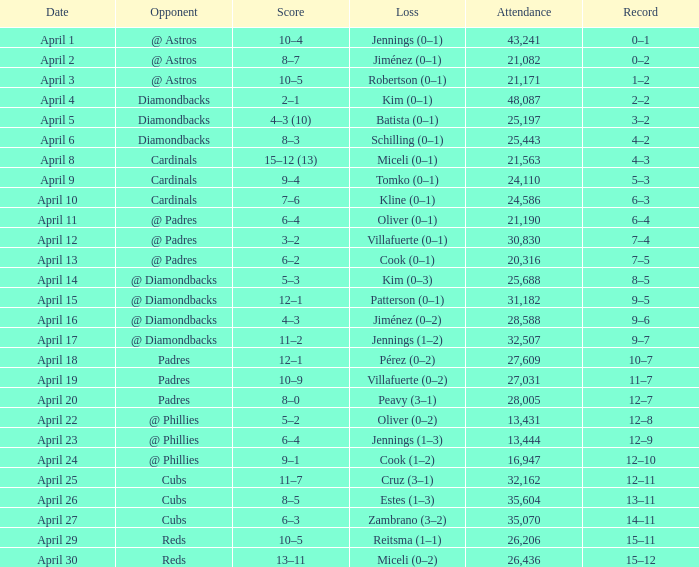On april 16, who is the adversary? @ Diamondbacks. 